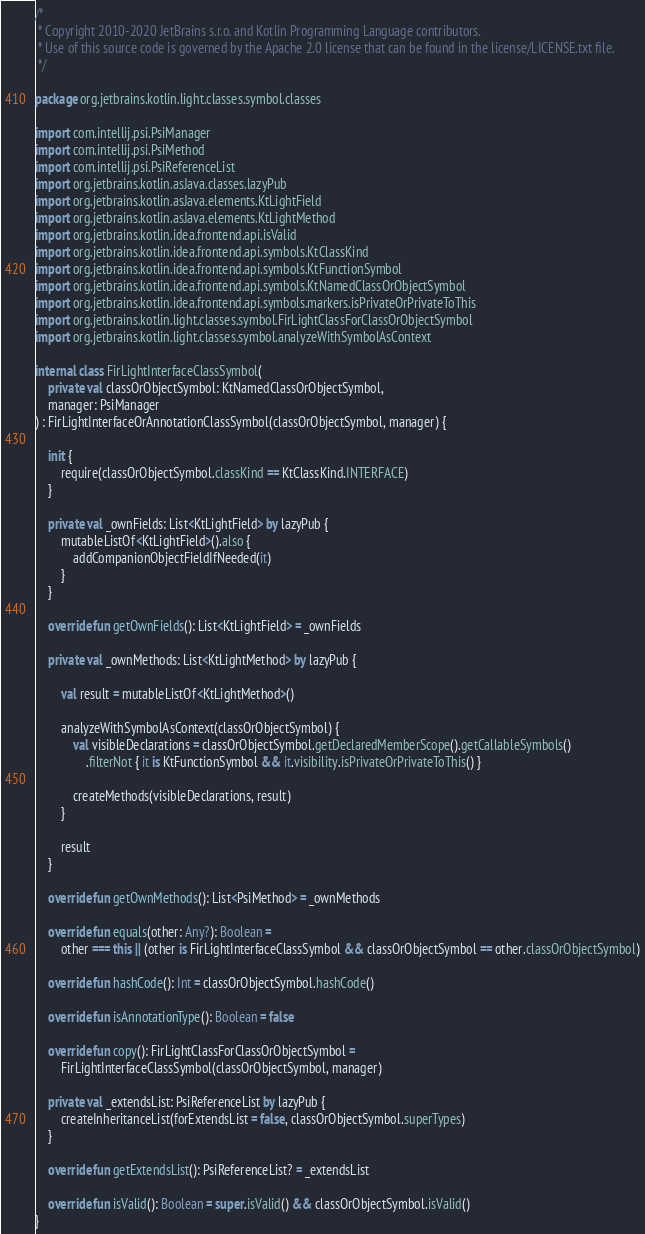Convert code to text. <code><loc_0><loc_0><loc_500><loc_500><_Kotlin_>/*
 * Copyright 2010-2020 JetBrains s.r.o. and Kotlin Programming Language contributors.
 * Use of this source code is governed by the Apache 2.0 license that can be found in the license/LICENSE.txt file.
 */

package org.jetbrains.kotlin.light.classes.symbol.classes

import com.intellij.psi.PsiManager
import com.intellij.psi.PsiMethod
import com.intellij.psi.PsiReferenceList
import org.jetbrains.kotlin.asJava.classes.lazyPub
import org.jetbrains.kotlin.asJava.elements.KtLightField
import org.jetbrains.kotlin.asJava.elements.KtLightMethod
import org.jetbrains.kotlin.idea.frontend.api.isValid
import org.jetbrains.kotlin.idea.frontend.api.symbols.KtClassKind
import org.jetbrains.kotlin.idea.frontend.api.symbols.KtFunctionSymbol
import org.jetbrains.kotlin.idea.frontend.api.symbols.KtNamedClassOrObjectSymbol
import org.jetbrains.kotlin.idea.frontend.api.symbols.markers.isPrivateOrPrivateToThis
import org.jetbrains.kotlin.light.classes.symbol.FirLightClassForClassOrObjectSymbol
import org.jetbrains.kotlin.light.classes.symbol.analyzeWithSymbolAsContext

internal class FirLightInterfaceClassSymbol(
    private val classOrObjectSymbol: KtNamedClassOrObjectSymbol,
    manager: PsiManager
) : FirLightInterfaceOrAnnotationClassSymbol(classOrObjectSymbol, manager) {

    init {
        require(classOrObjectSymbol.classKind == KtClassKind.INTERFACE)
    }

    private val _ownFields: List<KtLightField> by lazyPub {
        mutableListOf<KtLightField>().also {
            addCompanionObjectFieldIfNeeded(it)
        }
    }

    override fun getOwnFields(): List<KtLightField> = _ownFields

    private val _ownMethods: List<KtLightMethod> by lazyPub {

        val result = mutableListOf<KtLightMethod>()

        analyzeWithSymbolAsContext(classOrObjectSymbol) {
            val visibleDeclarations = classOrObjectSymbol.getDeclaredMemberScope().getCallableSymbols()
                .filterNot { it is KtFunctionSymbol && it.visibility.isPrivateOrPrivateToThis() }

            createMethods(visibleDeclarations, result)
        }

        result
    }

    override fun getOwnMethods(): List<PsiMethod> = _ownMethods

    override fun equals(other: Any?): Boolean =
        other === this || (other is FirLightInterfaceClassSymbol && classOrObjectSymbol == other.classOrObjectSymbol)

    override fun hashCode(): Int = classOrObjectSymbol.hashCode()

    override fun isAnnotationType(): Boolean = false

    override fun copy(): FirLightClassForClassOrObjectSymbol =
        FirLightInterfaceClassSymbol(classOrObjectSymbol, manager)

    private val _extendsList: PsiReferenceList by lazyPub {
        createInheritanceList(forExtendsList = false, classOrObjectSymbol.superTypes)
    }

    override fun getExtendsList(): PsiReferenceList? = _extendsList

    override fun isValid(): Boolean = super.isValid() && classOrObjectSymbol.isValid()
}</code> 